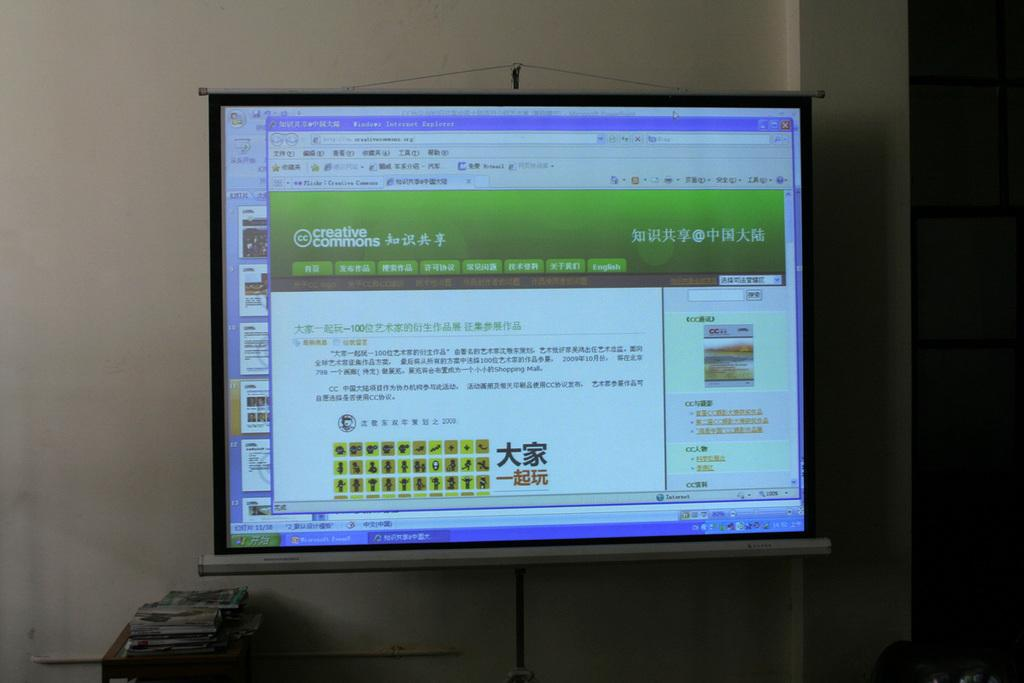What is the main feature of the image? There is a projection screen in the image. What is being displayed on the projection screen? There is a projection on the screen. What can be seen on the table in the image? There are books on a table in the image. What color is the wall in the background of the image? There is a white-colored wall in the background of the image. How does the silk on the projection screen affect the quality of the image? There is no silk present on the projection screen in the image. The projection screen is a flat surface designed to display images without any fabric or texture. 